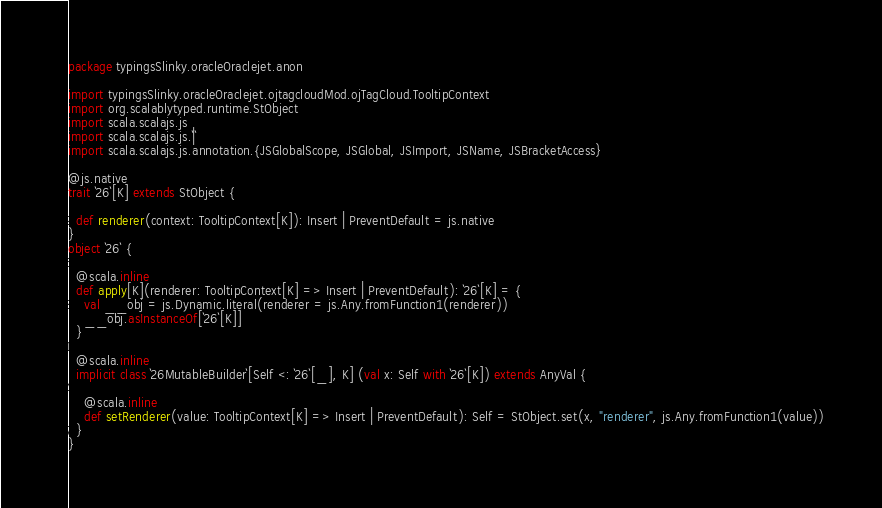<code> <loc_0><loc_0><loc_500><loc_500><_Scala_>package typingsSlinky.oracleOraclejet.anon

import typingsSlinky.oracleOraclejet.ojtagcloudMod.ojTagCloud.TooltipContext
import org.scalablytyped.runtime.StObject
import scala.scalajs.js
import scala.scalajs.js.`|`
import scala.scalajs.js.annotation.{JSGlobalScope, JSGlobal, JSImport, JSName, JSBracketAccess}

@js.native
trait `26`[K] extends StObject {
  
  def renderer(context: TooltipContext[K]): Insert | PreventDefault = js.native
}
object `26` {
  
  @scala.inline
  def apply[K](renderer: TooltipContext[K] => Insert | PreventDefault): `26`[K] = {
    val __obj = js.Dynamic.literal(renderer = js.Any.fromFunction1(renderer))
    __obj.asInstanceOf[`26`[K]]
  }
  
  @scala.inline
  implicit class `26MutableBuilder`[Self <: `26`[_], K] (val x: Self with `26`[K]) extends AnyVal {
    
    @scala.inline
    def setRenderer(value: TooltipContext[K] => Insert | PreventDefault): Self = StObject.set(x, "renderer", js.Any.fromFunction1(value))
  }
}
</code> 